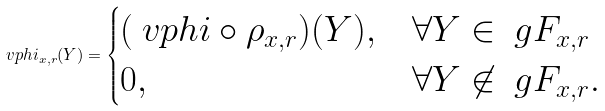Convert formula to latex. <formula><loc_0><loc_0><loc_500><loc_500>\ v p h i _ { x , r } ( Y ) = \begin{cases} ( \ v p h i \circ \rho _ { x , r } ) ( Y ) , & \forall Y \in \ g F _ { x , r } \\ 0 , & \forall Y \not \in \ g F _ { x , r } . \end{cases}</formula> 